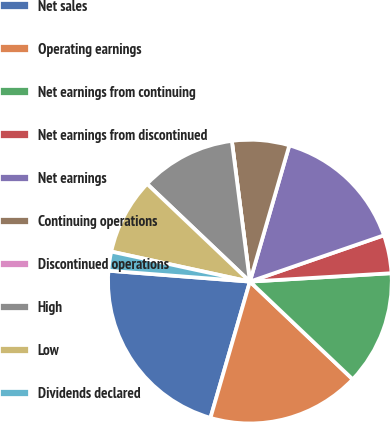Convert chart. <chart><loc_0><loc_0><loc_500><loc_500><pie_chart><fcel>Net sales<fcel>Operating earnings<fcel>Net earnings from continuing<fcel>Net earnings from discontinued<fcel>Net earnings<fcel>Continuing operations<fcel>Discontinued operations<fcel>High<fcel>Low<fcel>Dividends declared<nl><fcel>21.74%<fcel>17.39%<fcel>13.04%<fcel>4.35%<fcel>15.22%<fcel>6.52%<fcel>0.0%<fcel>10.87%<fcel>8.7%<fcel>2.17%<nl></chart> 